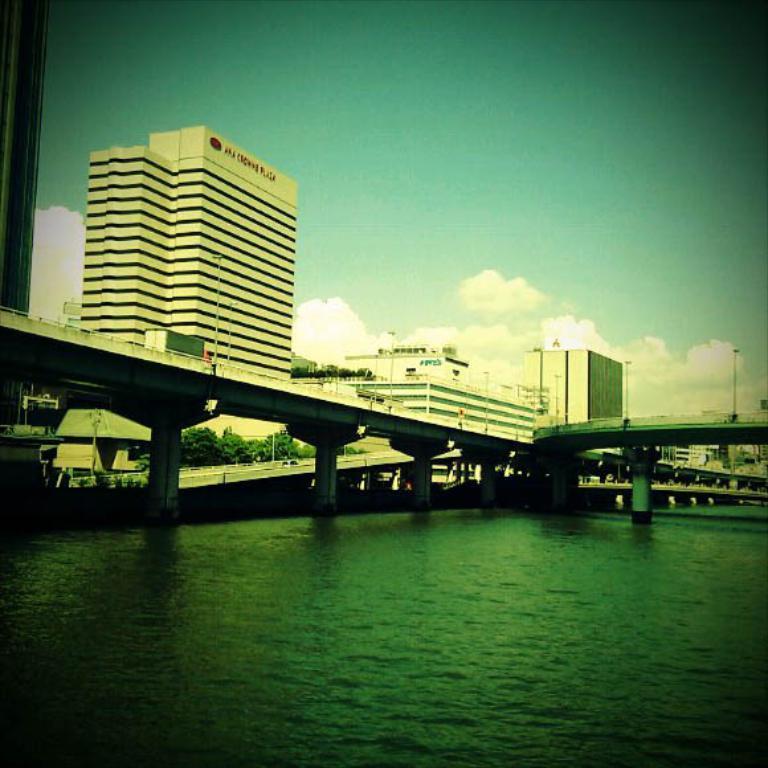Can you describe this image briefly? In this picture we can see buildings and bridge. On the bottom there is a water. At the top we can see sky and clouds. Here we can see street light, and fencing. 